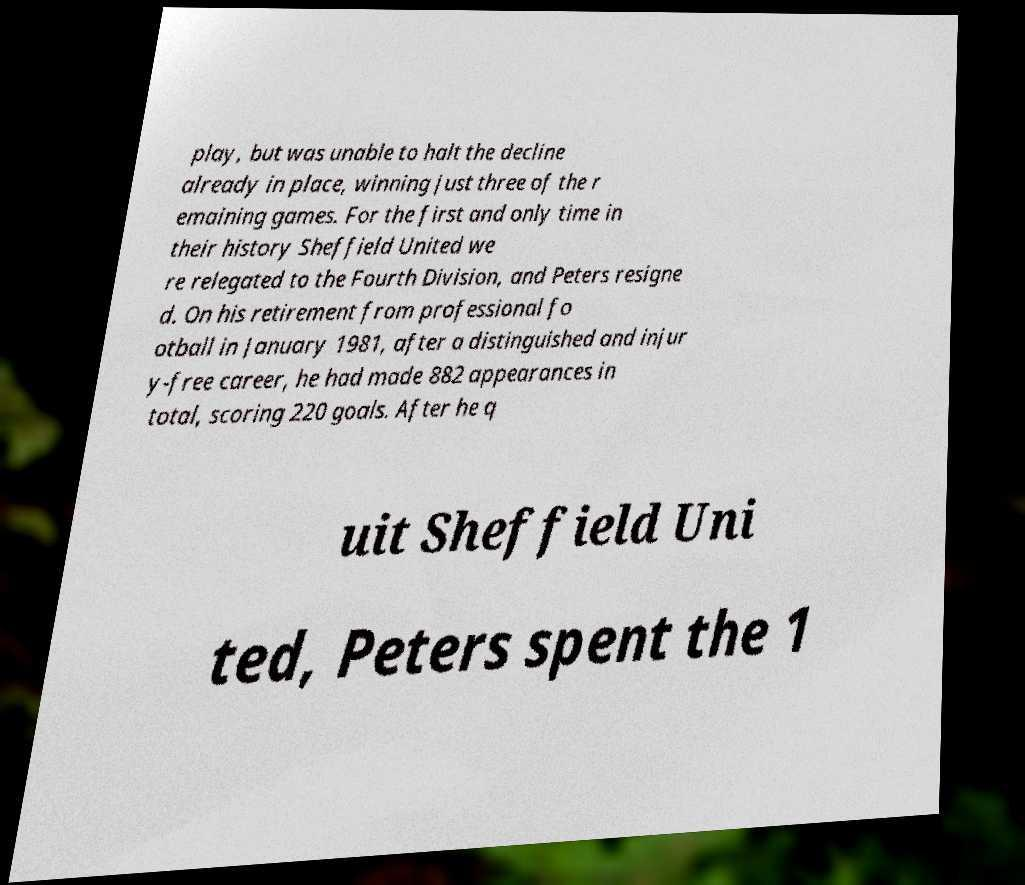Could you extract and type out the text from this image? play, but was unable to halt the decline already in place, winning just three of the r emaining games. For the first and only time in their history Sheffield United we re relegated to the Fourth Division, and Peters resigne d. On his retirement from professional fo otball in January 1981, after a distinguished and injur y-free career, he had made 882 appearances in total, scoring 220 goals. After he q uit Sheffield Uni ted, Peters spent the 1 